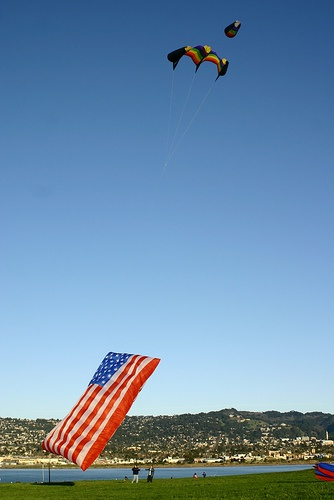Describe the objects in this image and their specific colors. I can see kite in blue, red, brown, and tan tones, kite in blue, black, maroon, navy, and olive tones, kite in blue, black, maroon, gray, and navy tones, people in blue, black, darkgray, gray, and lightgray tones, and people in blue, black, gray, darkgray, and olive tones in this image. 